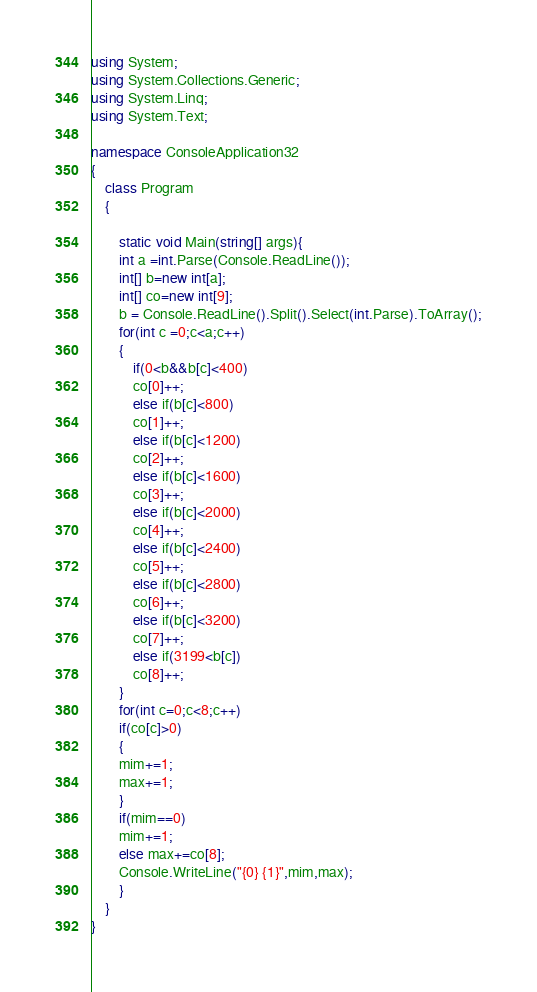<code> <loc_0><loc_0><loc_500><loc_500><_C#_>using System;
using System.Collections.Generic;
using System.Linq;
using System.Text;
  
namespace ConsoleApplication32
{
    class Program
    {
        
        static void Main(string[] args){
        int a =int.Parse(Console.ReadLine());
        int[] b=new int[a];
        int[] co=new int[9];
        b = Console.ReadLine().Split().Select(int.Parse).ToArray();
        for(int c =0;c<a;c++)
        {
        	if(0<b&&b[c]<400)
			co[0]++;
			else if(b[c]<800)
			co[1]++;
			else if(b[c]<1200)
			co[2]++;
			else if(b[c]<1600)
			co[3]++;
			else if(b[c]<2000)
			co[4]++;
			else if(b[c]<2400)
			co[5]++;
			else if(b[c]<2800)
			co[6]++;
			else if(b[c]<3200)
			co[7]++;
			else if(3199<b[c])
			co[8]++;
        }
        for(int c=0;c<8;c++)
        if(co[c]>0)
        {
        mim+=1;
        max+=1;
        }
        if(mim==0)
        mim+=1;
        else max+=co[8];
        Console.WriteLine("{0} {1}",mim,max);
        }
    }
}

</code> 